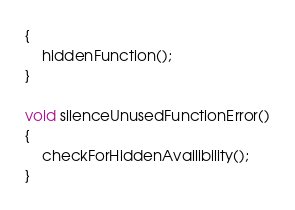Convert code to text. <code><loc_0><loc_0><loc_500><loc_500><_C++_>{
	hiddenFunction();
}

void silenceUnusedFunctionError()
{
	checkForHiddenAvailibility();
}
</code> 